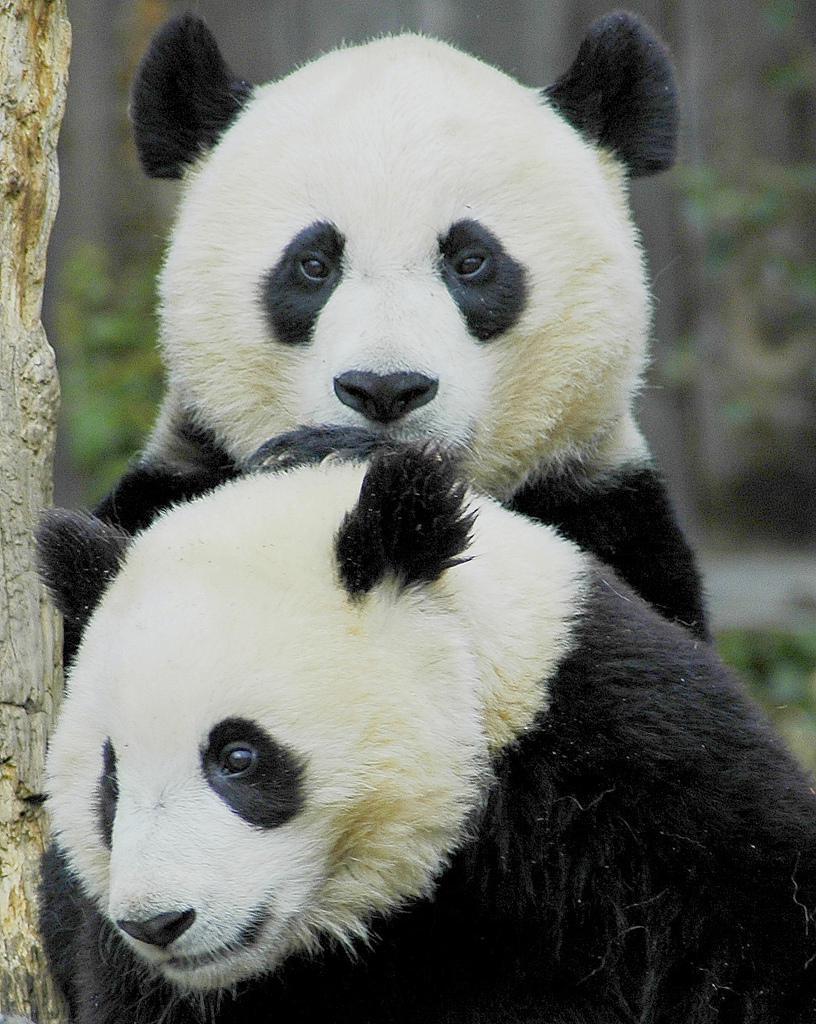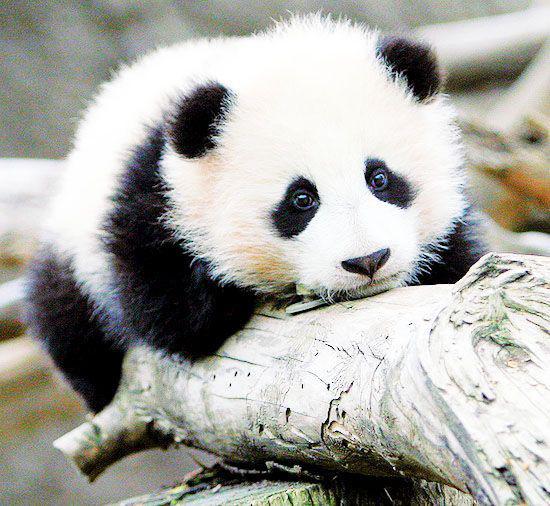The first image is the image on the left, the second image is the image on the right. Assess this claim about the two images: "One image shows two panda faces, with two sets of eyes visible.". Correct or not? Answer yes or no. Yes. 